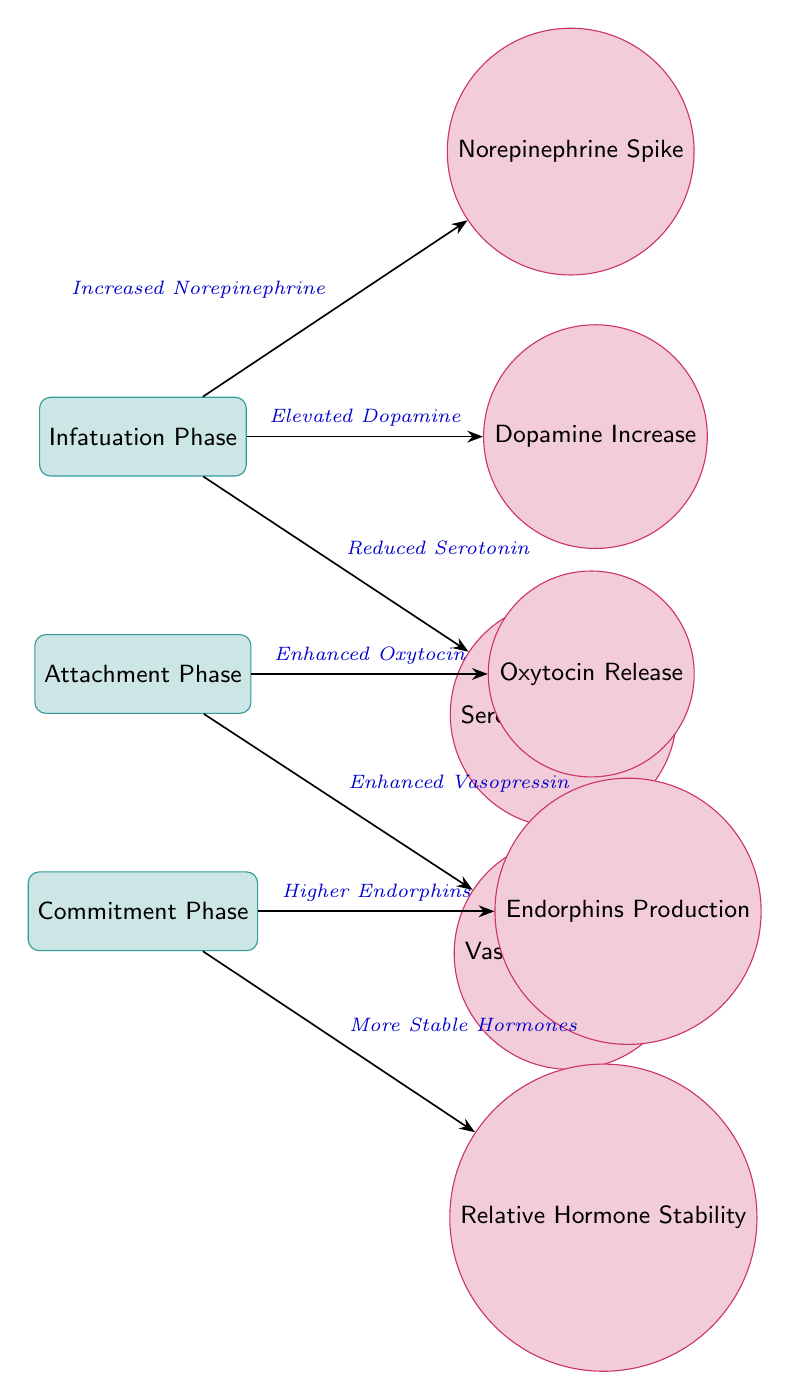What are the hormones associated with the Infatuation Phase? The diagram shows three specific hormones linked to the Infatuation Phase: dopamine, norepinephrine, and serotonin. These hormones are represented with connections indicating their increase or decrease during this phase.
Answer: Dopamine Increase, Norepinephrine Spike, Serotonin Decrease How many hormones are linked to the Attachment Phase? The diagram indicates two hormones related to the Attachment Phase: oxytocin and vasopressin, which are displayed in their respective positions. Therefore, we simply count these hormones to arrive at the answer.
Answer: 2 What is the relationship between the Attachment Phase and Oxytocin? The diagram clearly outlines that there is an enhancement of oxytocin as a key hormonal change during the Attachment Phase. The connection from the Attachment Phase to the Oxytocin node illustrates this enhancement.
Answer: Enhanced Oxytocin Which phase shows a Serotonin Decrease? The diagram specifies that the Infatuation Phase includes a Serotonin Decrease, indicating that this hormonal change occurs during that specific phase of a relationship.
Answer: Infatuation Phase What connects the Commitment Phase to the Endorphins Production? The diagram depicts a direct connection from the Commitment Phase to the Endorphins Production node. This edge indicates that the production of endorphins is higher in the Commitment Phase compared to the previous stages.
Answer: Higher Endorphins What conveys the concept of "Relative Hormone Stability" in the diagram? The final phase illustrated in the diagram is the Commitment Phase, which leads to the concept of relative hormone stability represented in a separate node connected to it. This indicates a more balanced hormonal profile compared to earlier phases.
Answer: More Stable Hormones How are the Hormones for different phases connected in the diagram? The diagram presents a series of connections where each phase is linked to specific hormonal changes. These edges logically flow from one phase to the next, showing progression through infatuation to attachment and finally commitment, clarifying how hormones influence each stage sequentially.
Answer: Sequential connections What are the main phases illustrated in the diagram? The diagram highlights three key phases: Infatuation Phase, Attachment Phase, and Commitment Phase, each represented as distinct nodes which categorize the hormonal changes occurring at different stages of a relationship.
Answer: Infatuation, Attachment, Commitment 